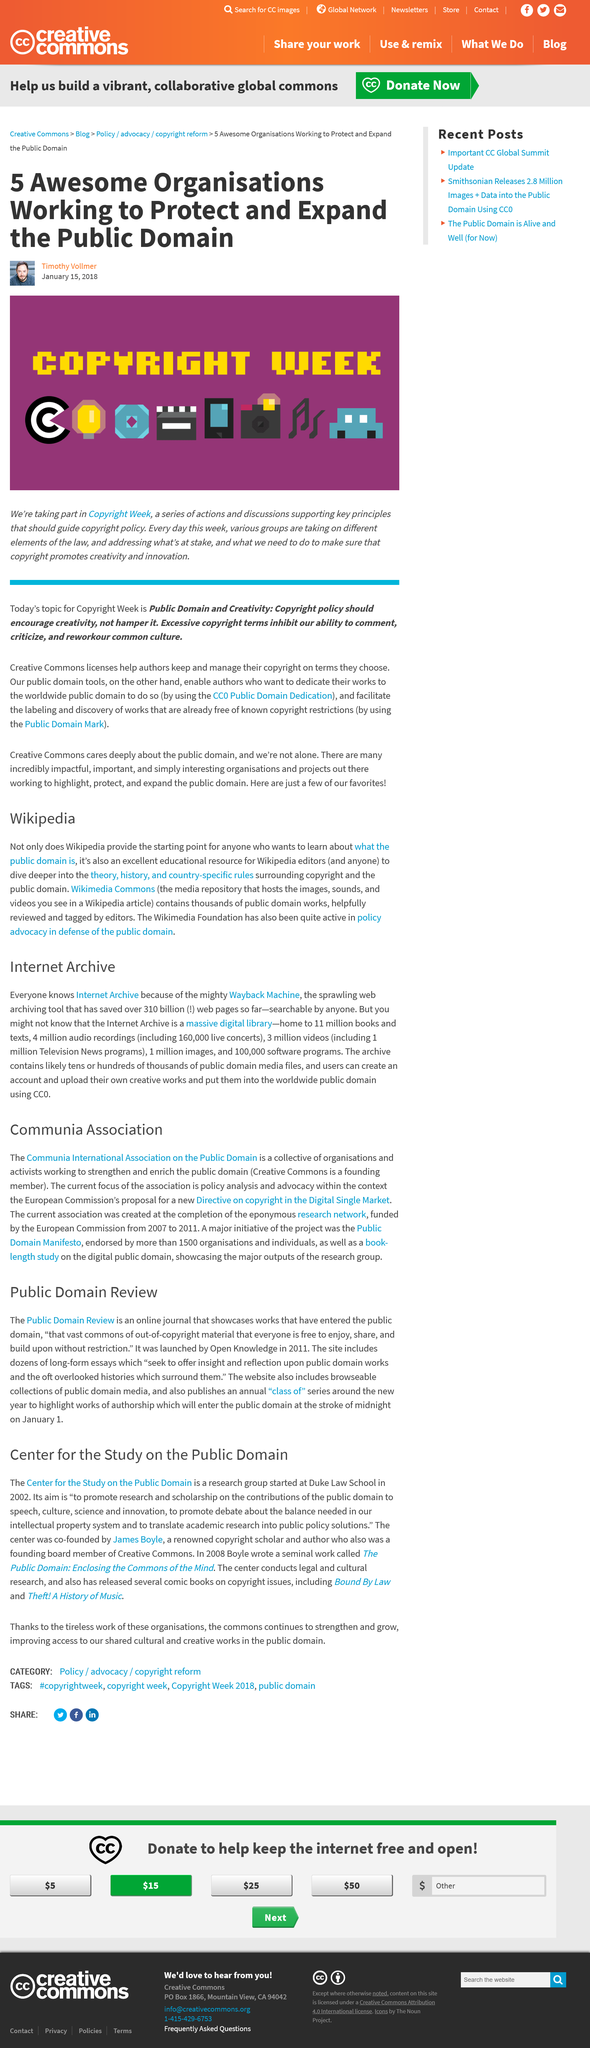Indicate a few pertinent items in this graphic. The Public Domain Review is a digital journal that features works that have fallen into the public domain. Public Domain Review was launched by Open Knowledge. The Internet Archive holds 11 million books and texts in total. The annual "class of" series is published on January 1. There are approximately 1 million Television News programs available in the Internet Archive. 